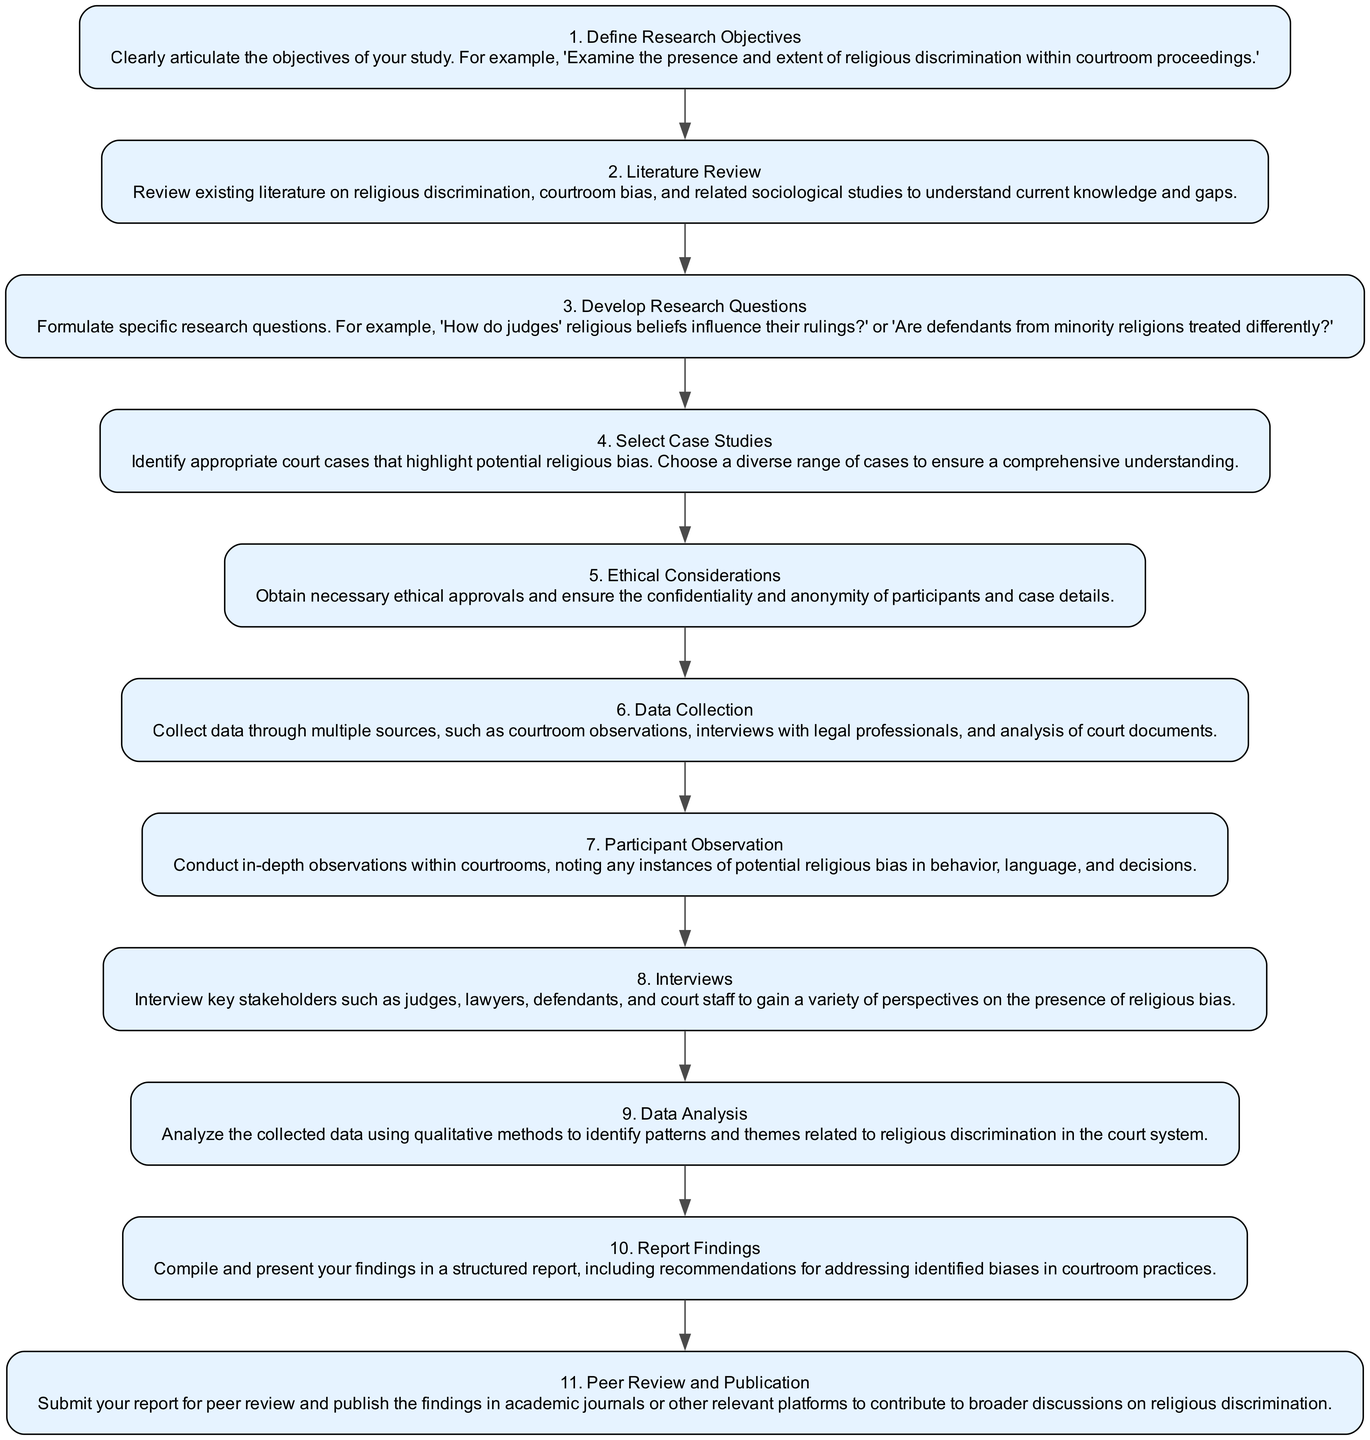What is the first step in the ethnographic study process? The first step is clearly defined as "Define Research Objectives" in the diagram. This step articulates the goals of the research.
Answer: Define Research Objectives How many total steps are there in the diagram? By counting each step listed in the diagram, there are 11 distinct steps in the process of conducting an ethnographic study.
Answer: 11 What follows after the "Select Case Studies" step? In the diagram, the "Ethical Considerations" step directly follows "Select Case Studies," indicating the next action to take after selecting cases.
Answer: Ethical Considerations What is the step that involves interviewing key stakeholders? The step labeled "Interviews" specifies the action of interviewing various stakeholders to gather diverse perspectives on religious bias.
Answer: Interviews What are the two steps that follow "Data Collection"? The steps that follow "Data Collection" are "Participant Observation" and "Interviews" as shown in the flow chart outlining the study steps.
Answer: Participant Observation, Interviews Which step focuses on revealing patterns and themes? The "Data Analysis" step is where the collected data is analyzed to reveal patterns and themes regarding religious discrimination.
Answer: Data Analysis What is required before initiating any data collection? According to the diagram, the step called "Ethical Considerations" must be addressed to ensure ethical approval and participant confidentiality before starting data collection.
Answer: Ethical Considerations What is the final step in the diagram? The last step as depicted in the flow chart is "Peer Review and Publication," which involves submitting the findings for review and publication.
Answer: Peer Review and Publication What type of data collection does the "Participant Observation" step include? The "Participant Observation" step emphasizes the importance of conducting in-depth observations within courtrooms specifically related to potential religious bias.
Answer: In-depth observations 